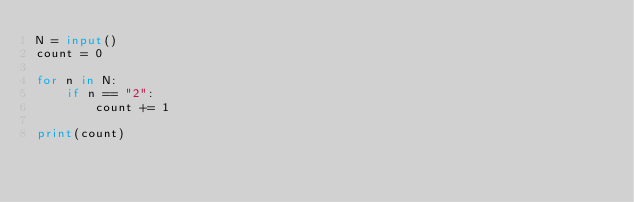Convert code to text. <code><loc_0><loc_0><loc_500><loc_500><_Python_>N = input()
count = 0

for n in N:
    if n == "2":
        count += 1
        
print(count)</code> 